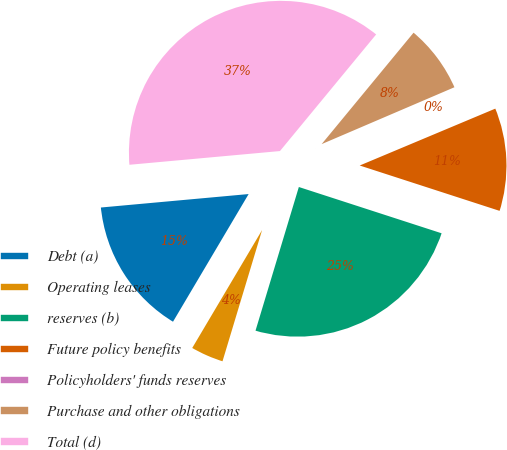Convert chart to OTSL. <chart><loc_0><loc_0><loc_500><loc_500><pie_chart><fcel>Debt (a)<fcel>Operating leases<fcel>reserves (b)<fcel>Future policy benefits<fcel>Policyholders' funds reserves<fcel>Purchase and other obligations<fcel>Total (d)<nl><fcel>15.04%<fcel>3.85%<fcel>24.67%<fcel>11.31%<fcel>0.12%<fcel>7.58%<fcel>37.42%<nl></chart> 